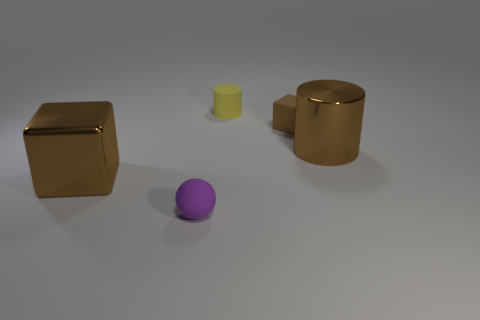Add 1 purple cylinders. How many objects exist? 6 Subtract all cylinders. How many objects are left? 3 Add 5 tiny matte spheres. How many tiny matte spheres are left? 6 Add 1 small cyan metal objects. How many small cyan metal objects exist? 1 Subtract 0 brown spheres. How many objects are left? 5 Subtract all tiny blue things. Subtract all matte balls. How many objects are left? 4 